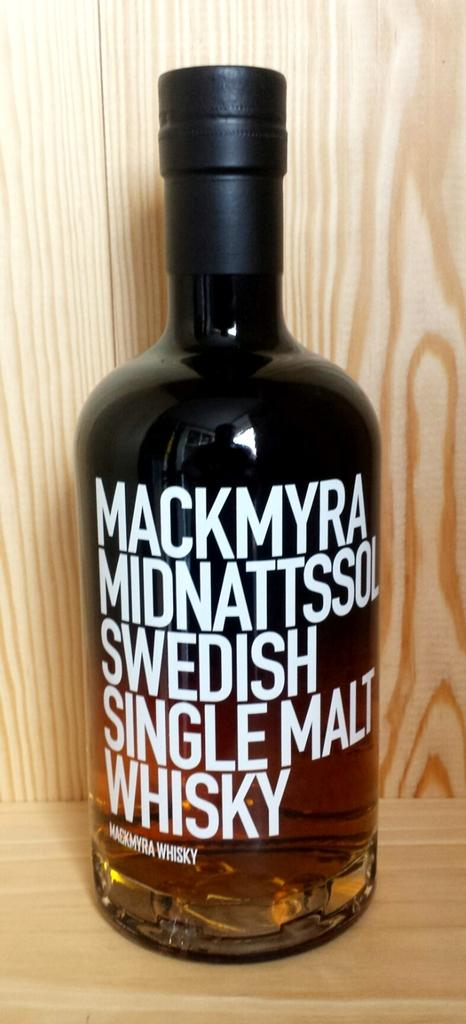What object is present in the image? There is a bottle in the image. What is the color of the bottle? The bottle is black in color. What is inside the bottle? The bottle contains whiskey. How is the bottle stored in the image? The bottle is kept in a wooden rack. Reasoning: Let' Let's think step by step in order to produce the conversation. We start by identifying the main object in the image, which is the bottle. Then, we describe the bottle's color and contents, as well as its storage method. Each question is designed to elicit a specific detail about the image that is known from the provided facts. Absurd Question/Answer: What type of guide can be seen in the image? There is no guide present in the image; it features a black bottle containing whiskey and stored in a wooden rack. What kind of birds are perched on the bottle in the image? There are no birds present in the image; it features a black bottle containing whiskey and stored in a wooden rack. 